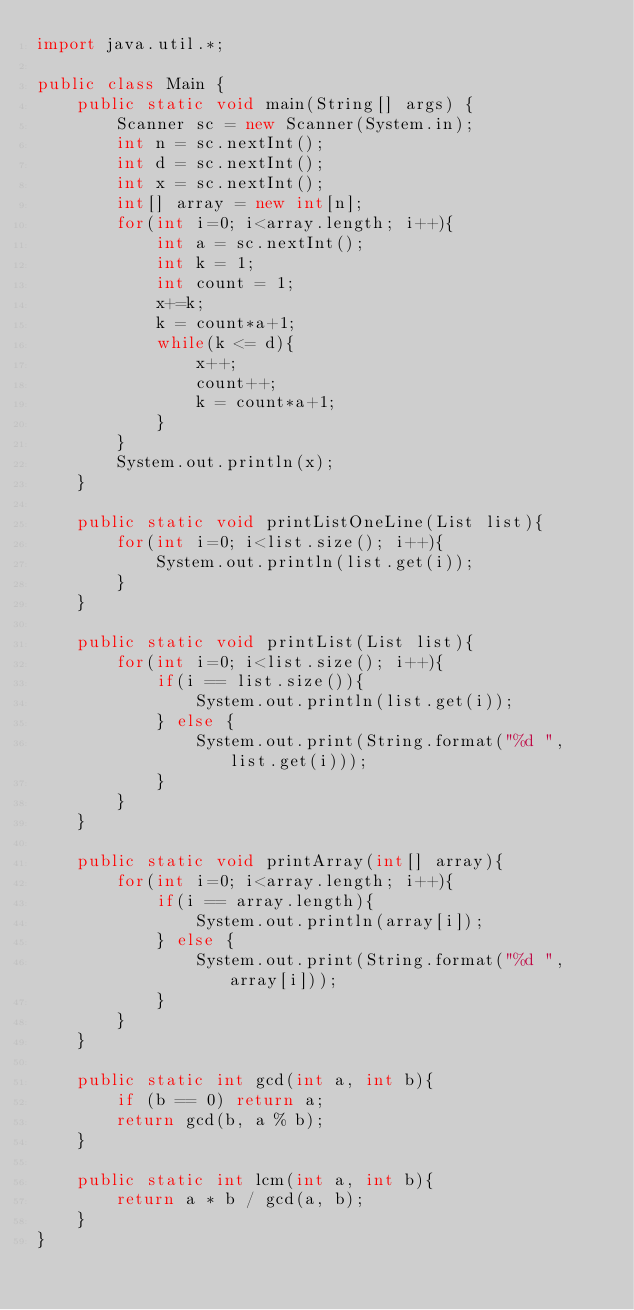<code> <loc_0><loc_0><loc_500><loc_500><_Java_>import java.util.*;

public class Main {
    public static void main(String[] args) {
        Scanner sc = new Scanner(System.in);
        int n = sc.nextInt();
        int d = sc.nextInt();
        int x = sc.nextInt();
        int[] array = new int[n];
        for(int i=0; i<array.length; i++){
            int a = sc.nextInt();
            int k = 1;
            int count = 1;
            x+=k;
            k = count*a+1;
            while(k <= d){
                x++;
                count++;
                k = count*a+1;
            }
        }
        System.out.println(x);
    }

    public static void printListOneLine(List list){
        for(int i=0; i<list.size(); i++){
            System.out.println(list.get(i));
        }
    }

    public static void printList(List list){
        for(int i=0; i<list.size(); i++){
            if(i == list.size()){
                System.out.println(list.get(i));
            } else {
                System.out.print(String.format("%d ", list.get(i)));
            }
        }
    }

    public static void printArray(int[] array){
        for(int i=0; i<array.length; i++){
            if(i == array.length){
                System.out.println(array[i]);
            } else {
                System.out.print(String.format("%d ", array[i]));
            }
        }
    }

    public static int gcd(int a, int b){
        if (b == 0) return a;
        return gcd(b, a % b);
    }

    public static int lcm(int a, int b){
        return a * b / gcd(a, b);
    }
}
</code> 